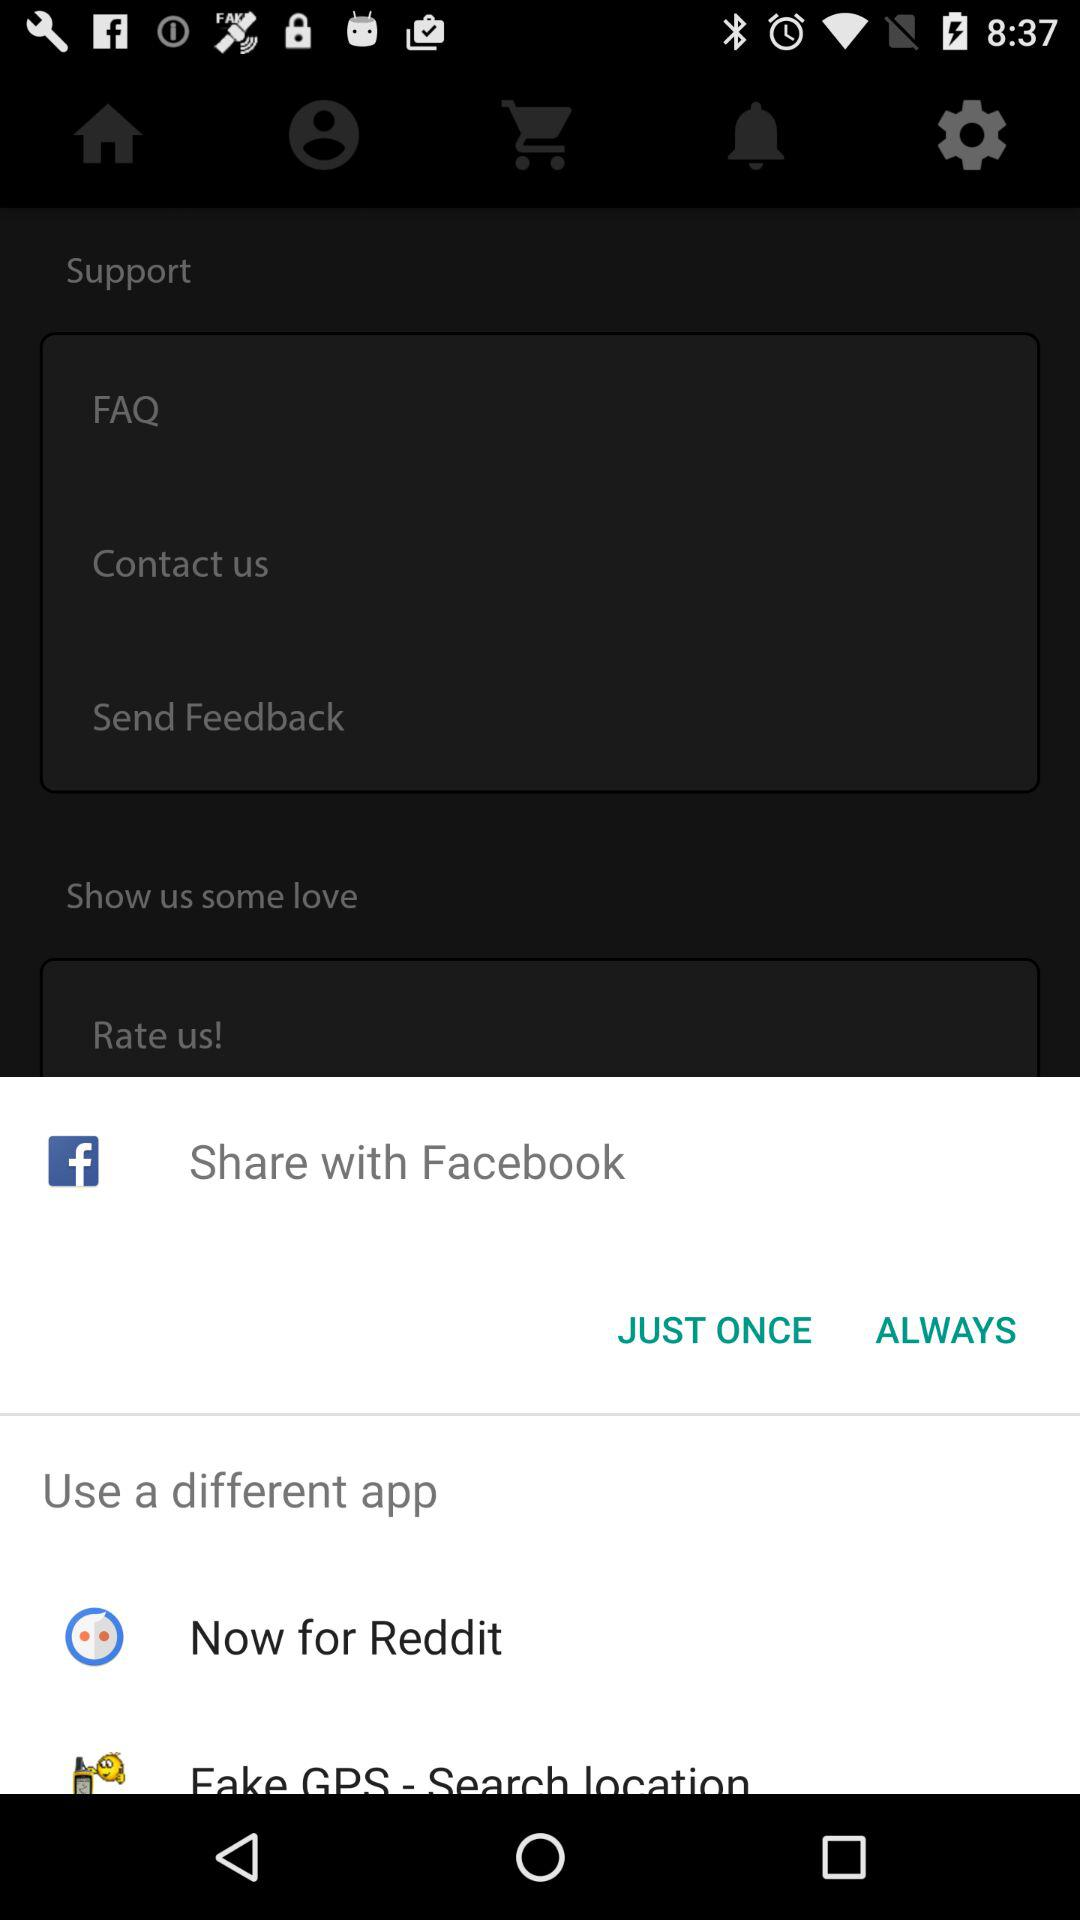What are the different apps I can use? The different apps you can use are "Now for Reddit" and "Fake GPS - Search location". 